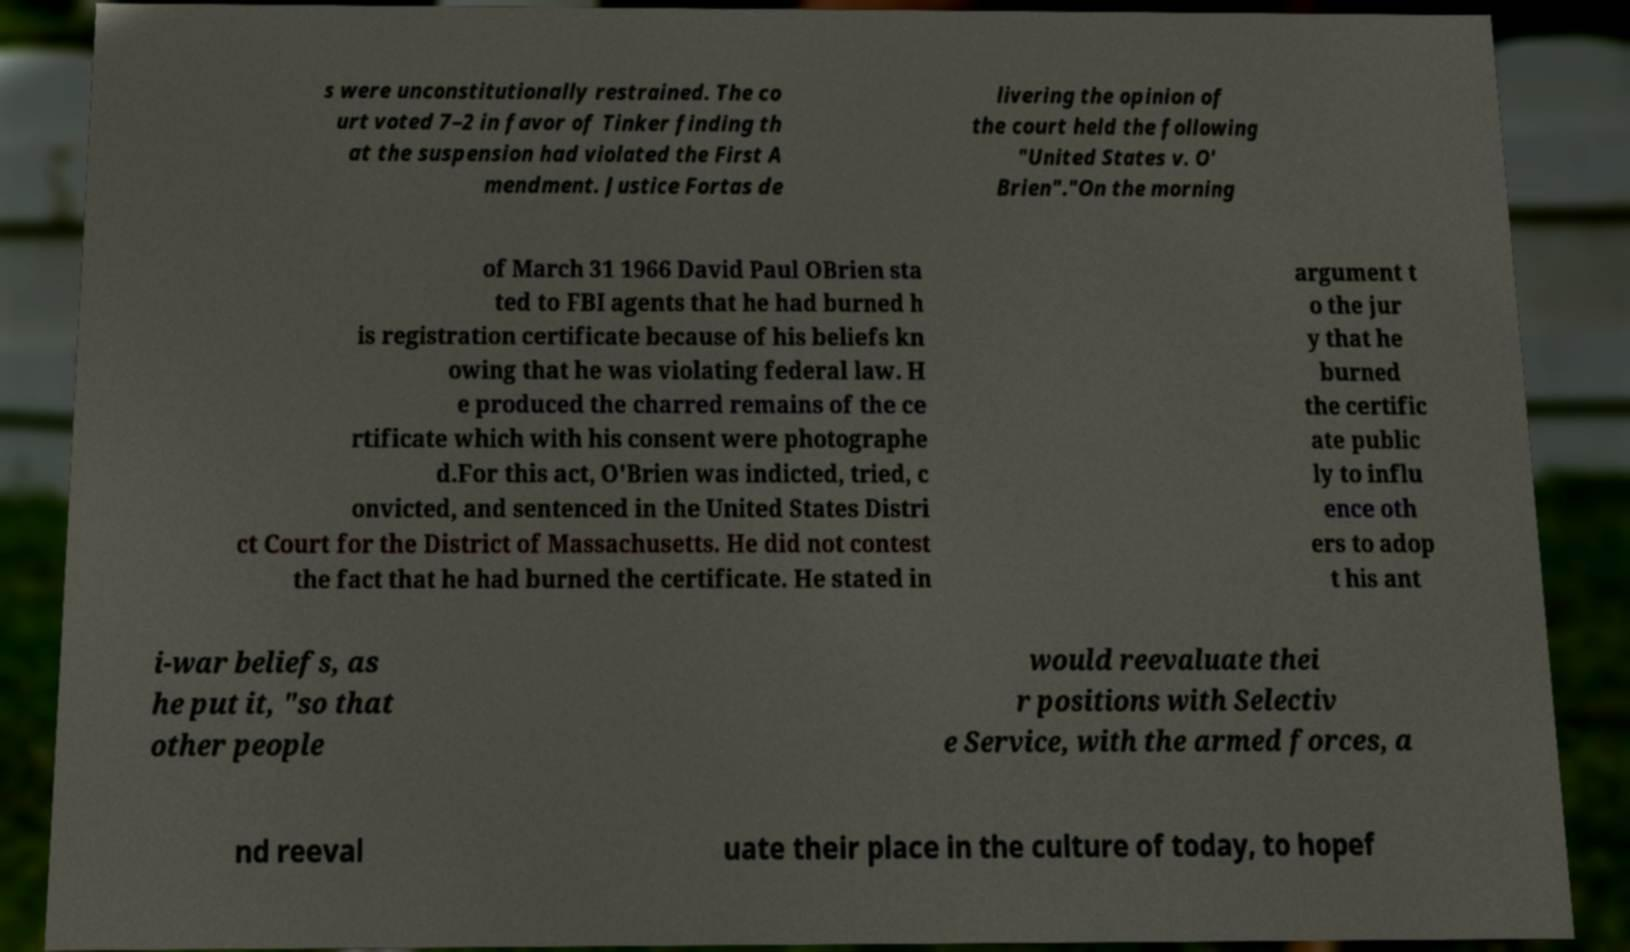Can you read and provide the text displayed in the image?This photo seems to have some interesting text. Can you extract and type it out for me? s were unconstitutionally restrained. The co urt voted 7–2 in favor of Tinker finding th at the suspension had violated the First A mendment. Justice Fortas de livering the opinion of the court held the following "United States v. O' Brien"."On the morning of March 31 1966 David Paul OBrien sta ted to FBI agents that he had burned h is registration certificate because of his beliefs kn owing that he was violating federal law. H e produced the charred remains of the ce rtificate which with his consent were photographe d.For this act, O'Brien was indicted, tried, c onvicted, and sentenced in the United States Distri ct Court for the District of Massachusetts. He did not contest the fact that he had burned the certificate. He stated in argument t o the jur y that he burned the certific ate public ly to influ ence oth ers to adop t his ant i-war beliefs, as he put it, "so that other people would reevaluate thei r positions with Selectiv e Service, with the armed forces, a nd reeval uate their place in the culture of today, to hopef 